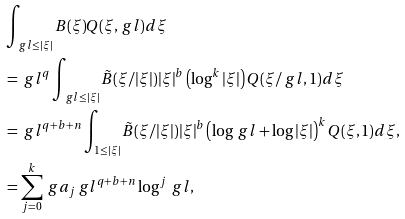<formula> <loc_0><loc_0><loc_500><loc_500>& \int _ { \ g l \leq | \xi | } B ( \xi ) Q ( \xi , \ g l ) d \xi \\ & = \ g l ^ { q } \int _ { \ g l \leq | \xi | } \tilde { B } ( \xi / | \xi | ) | \xi | ^ { b } \left ( \log ^ { k } | \xi | \right ) Q ( \xi / \ g l , 1 ) d \xi \\ & = \ g l ^ { q + b + n } \int _ { 1 \leq | \xi | } \tilde { B } ( \xi / | \xi | ) | \xi | ^ { b } \left ( \log \ g l + \log | \xi | \right ) ^ { k } Q ( \xi , 1 ) d \xi , \\ & = \sum _ { j = 0 } ^ { k } \ g a _ { j } \ g l ^ { q + b + n } \log ^ { j } \ g l ,</formula> 